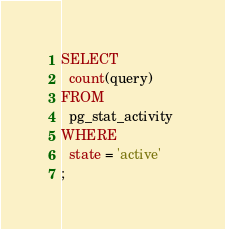Convert code to text. <code><loc_0><loc_0><loc_500><loc_500><_SQL_>SELECT 
  count(query) 
FROM 
  pg_stat_activity 
WHERE 
  state = 'active'
;
</code> 